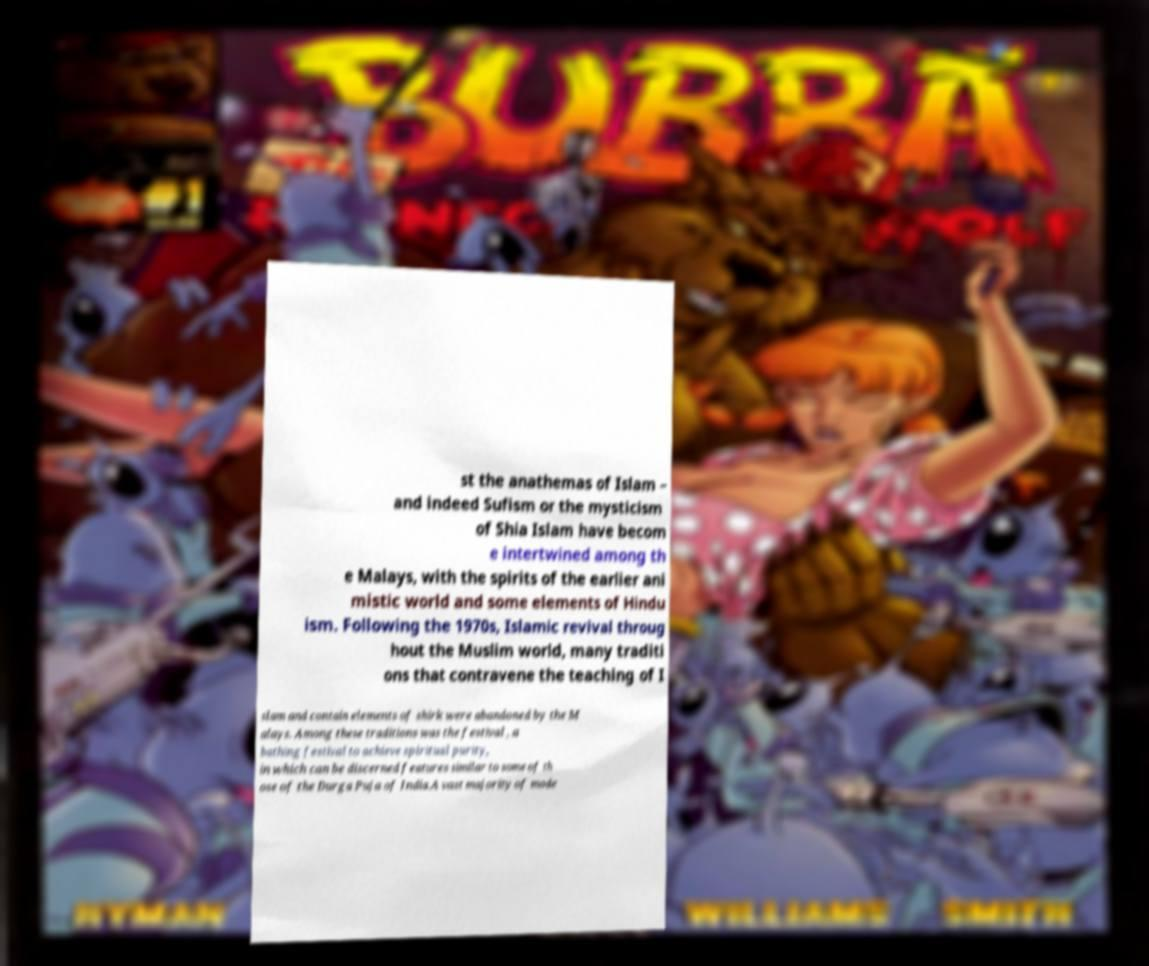Could you assist in decoding the text presented in this image and type it out clearly? st the anathemas of Islam – and indeed Sufism or the mysticism of Shia Islam have becom e intertwined among th e Malays, with the spirits of the earlier ani mistic world and some elements of Hindu ism. Following the 1970s, Islamic revival throug hout the Muslim world, many traditi ons that contravene the teaching of I slam and contain elements of shirk were abandoned by the M alays. Among these traditions was the festival , a bathing festival to achieve spiritual purity, in which can be discerned features similar to some of th ose of the Durga Puja of India.A vast majority of mode 